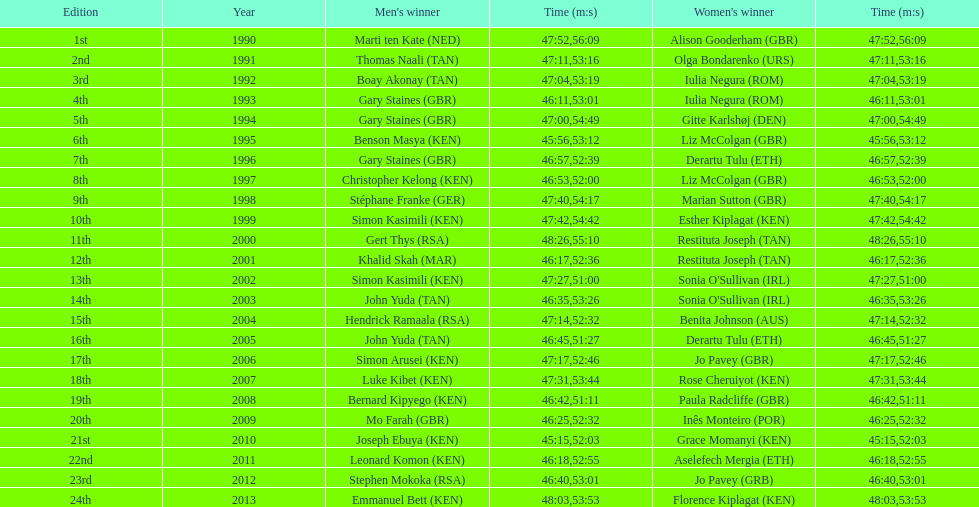Who has the fastest recorded finish for the men's bupa great south run, between 1990 and 2013? Joseph Ebuya (KEN). 